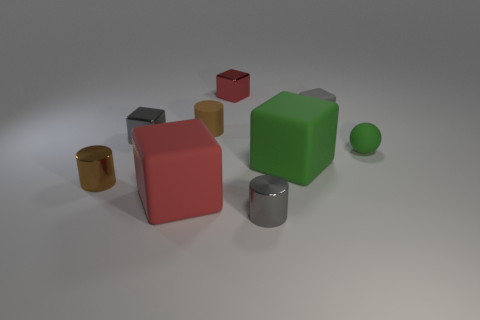Subtract all red metal blocks. How many blocks are left? 4 Subtract all green cubes. How many cubes are left? 4 Subtract all blue blocks. Subtract all cyan spheres. How many blocks are left? 5 Add 1 gray things. How many objects exist? 10 Subtract all cylinders. How many objects are left? 6 Subtract 0 purple spheres. How many objects are left? 9 Subtract all small gray rubber cubes. Subtract all gray matte objects. How many objects are left? 7 Add 4 tiny gray cylinders. How many tiny gray cylinders are left? 5 Add 4 large cylinders. How many large cylinders exist? 4 